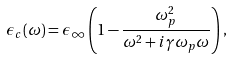Convert formula to latex. <formula><loc_0><loc_0><loc_500><loc_500>\epsilon _ { c } ( \omega ) = \epsilon _ { \infty } \left ( 1 - \frac { \omega _ { p } ^ { 2 } } { \omega ^ { 2 } + i \gamma \omega _ { p } \omega } \right ) ,</formula> 